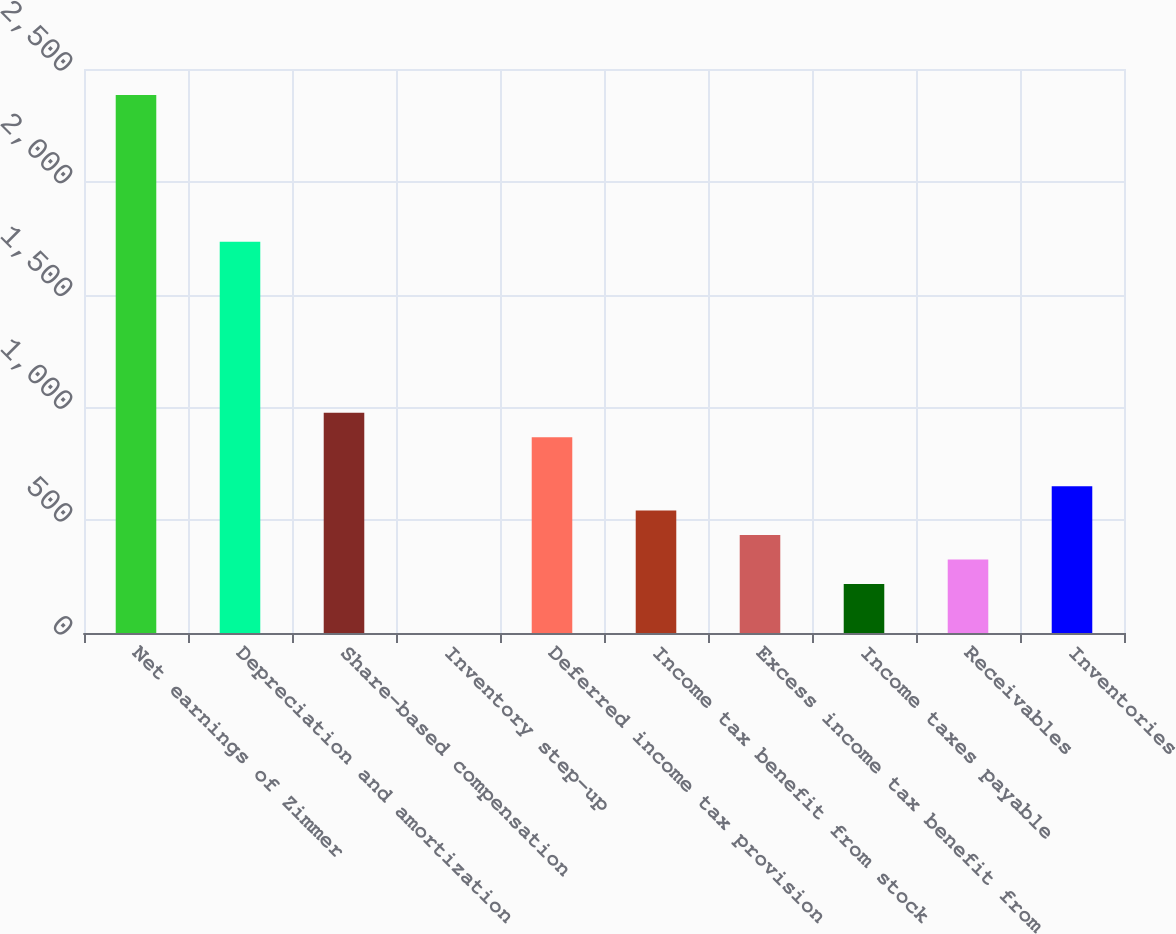Convert chart to OTSL. <chart><loc_0><loc_0><loc_500><loc_500><bar_chart><fcel>Net earnings of Zimmer<fcel>Depreciation and amortization<fcel>Share-based compensation<fcel>Inventory step-up<fcel>Deferred income tax provision<fcel>Income tax benefit from stock<fcel>Excess income tax benefit from<fcel>Income taxes payable<fcel>Receivables<fcel>Inventories<nl><fcel>2385.08<fcel>1734.74<fcel>976.01<fcel>0.5<fcel>867.62<fcel>542.45<fcel>434.06<fcel>217.28<fcel>325.67<fcel>650.84<nl></chart> 